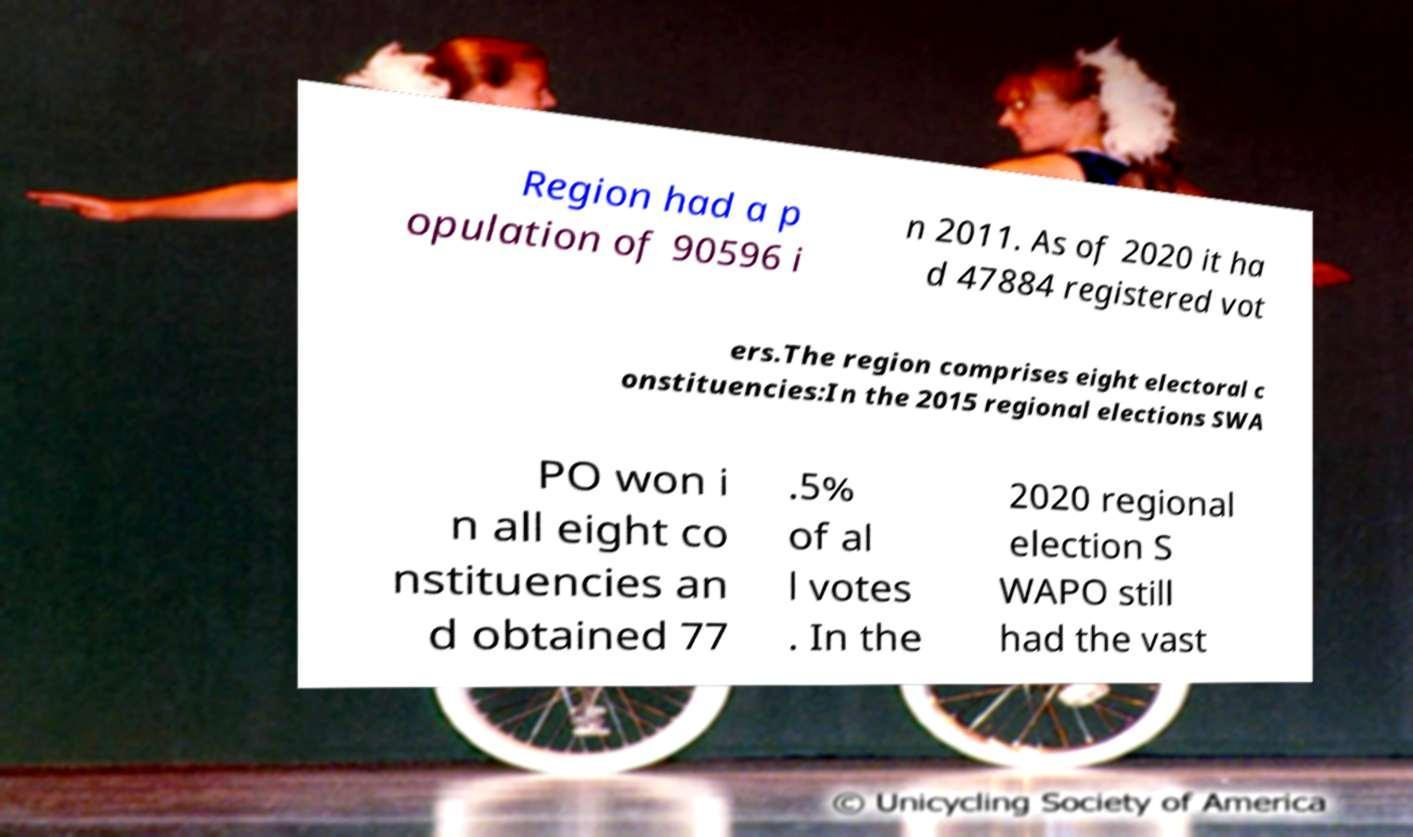Can you read and provide the text displayed in the image?This photo seems to have some interesting text. Can you extract and type it out for me? Region had a p opulation of 90596 i n 2011. As of 2020 it ha d 47884 registered vot ers.The region comprises eight electoral c onstituencies:In the 2015 regional elections SWA PO won i n all eight co nstituencies an d obtained 77 .5% of al l votes . In the 2020 regional election S WAPO still had the vast 